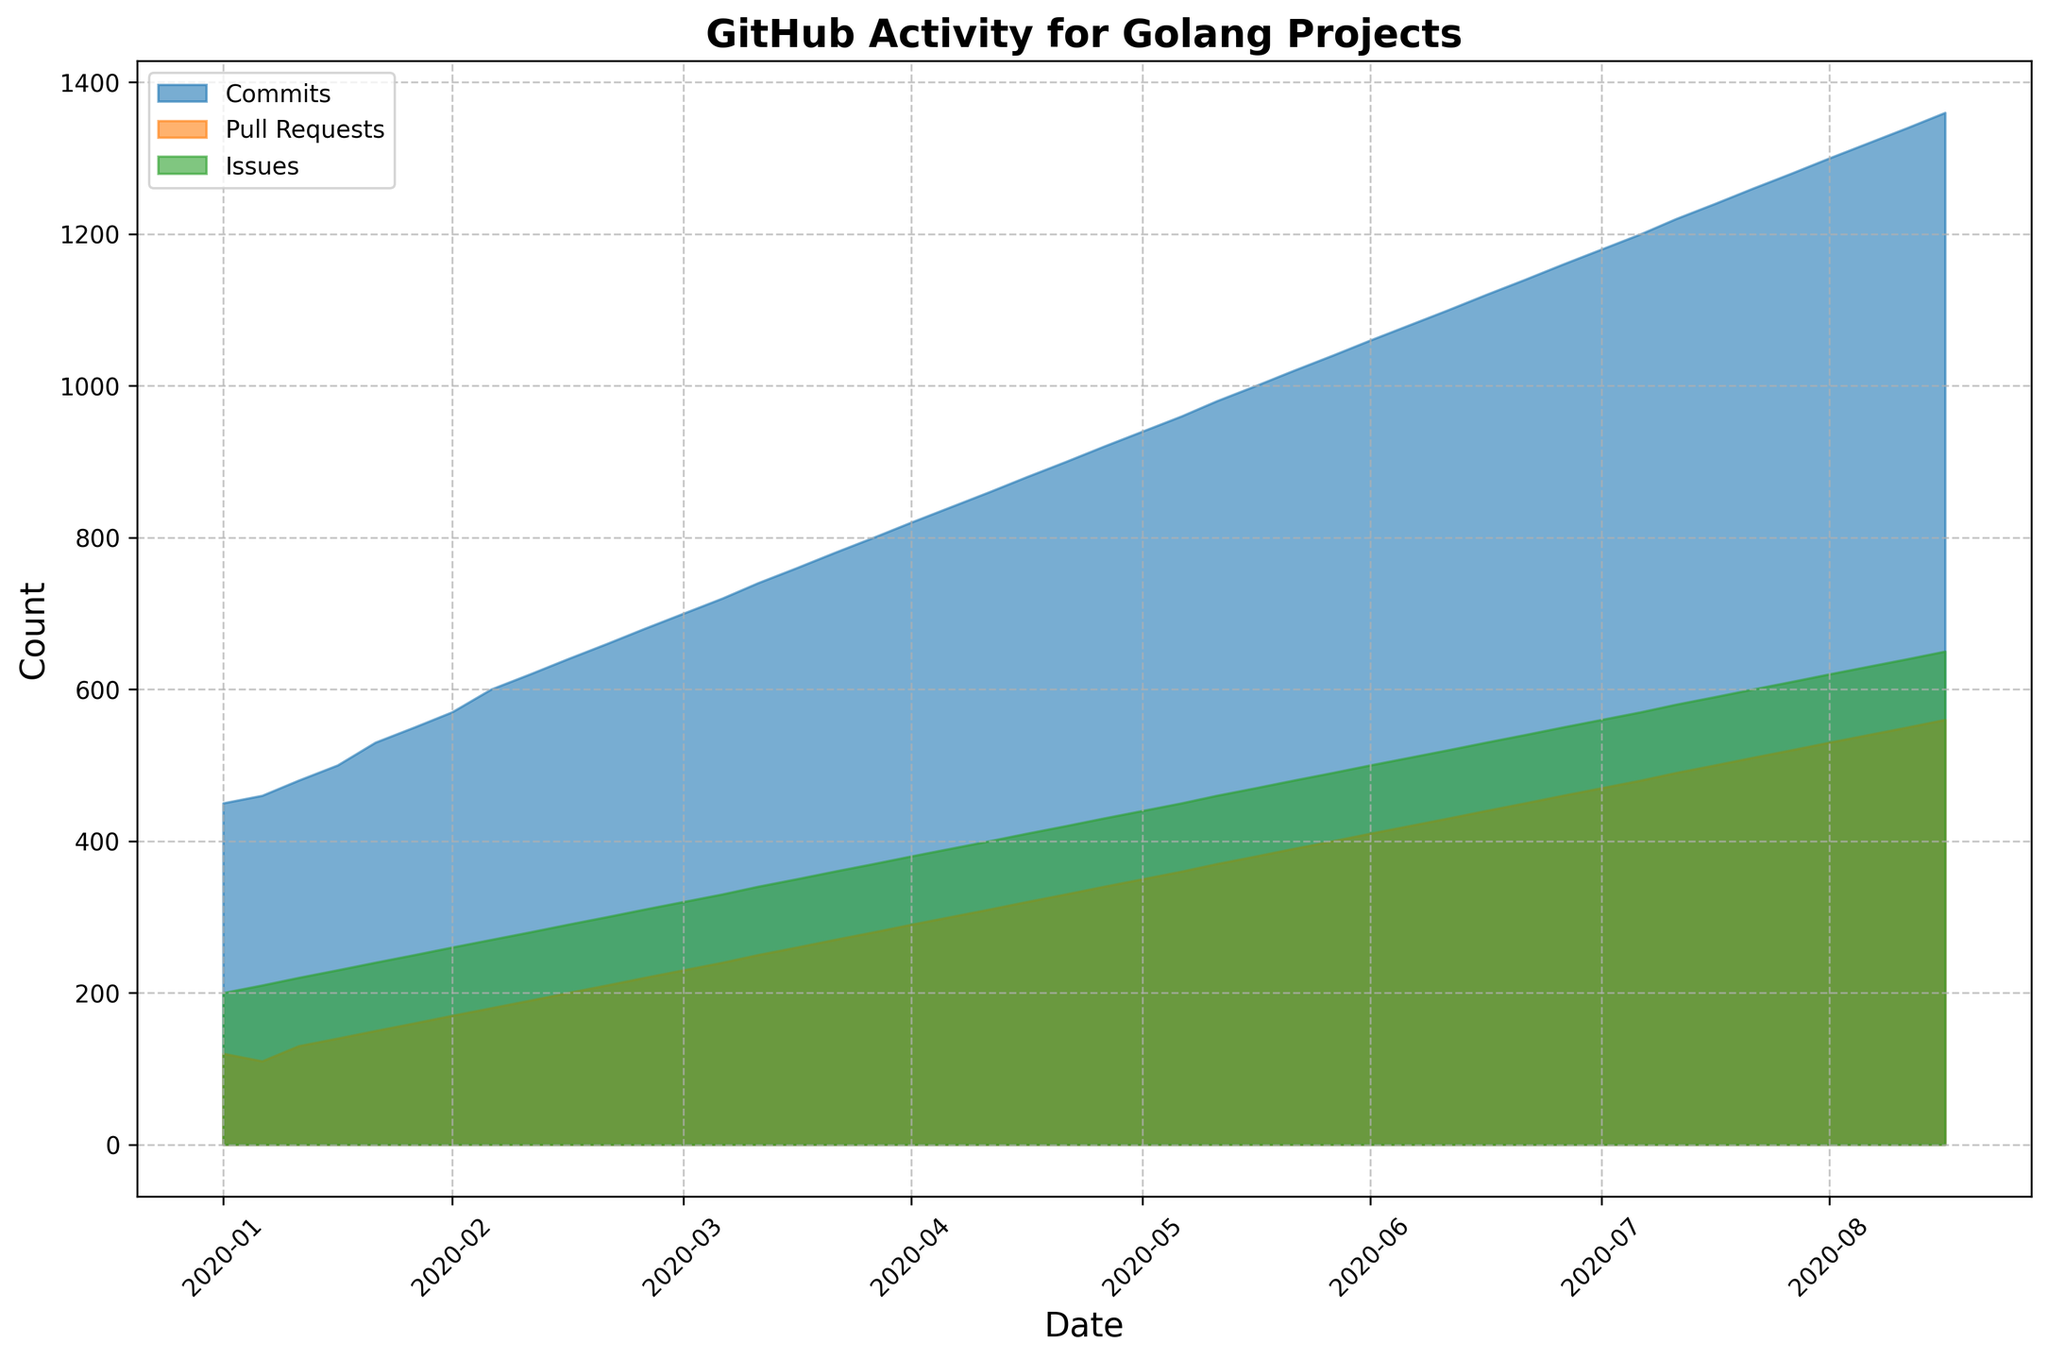Which activity type shows the greatest increase from January 2020 to October 2023? Compare the values for each activity type in January 2020 and October 2023. Calculate the difference for Commits (1360 - 450 = 910), Pull Requests (560 - 120 = 440), and Issues (650 - 200 = 450). Commits show the greatest increase.
Answer: Commits Which month shows the highest overall activity for Commits? Observe the highest point of the Commits area on the chart. It peaks in October 2023.
Answer: October 2023 How does the number of Issues in October 2023 compare with the number of Pull Requests in January 2023? Check the plot values for Issues in October 2023 (650) and Pull Requests in January 2023 (470). The number of Issues is higher.
Answer: Issues are higher In which year was the largest incremental increase in Pull Requests? Look at the annual increments in Pull Requests: January 2020 to December 2020 (220-120=100), January 2021 to December 2021 (340-230=110), and January 2022 to December 2022 (460-350=110). Both 2021 and 2022 show the largest incremental increase.
Answer: 2021 and 2022 What's the average number of Issues reported per month in 2021? Sum up the number of Issues for each month in 2021, which is 4200, then divide by 12. 4200 / 12 = 350
Answer: 350 Is there any month where Pull Requests exceeded Commits? Check the y-values of the respective areas month by month. There is no month where Pull Requests exceed Commits.
Answer: No From April 2022 to October 2023, how much did the number of Commits increase? Calculate the number of Commits in April 2022 (1000) and in October 2023 (1360). The increase is 1360 - 1000 = 360.
Answer: 360 Which activity type shows more consistent growth over the observed period? By visually inspecting the slope of each area's height, Commits show the most consistent growth with a steady upward trajectory.
Answer: Commits What is the pattern of activity during the first quarter each year? Observe the plots for January to March each year. All activities show an increasing pattern in each first quarter.
Answer: Increasing 